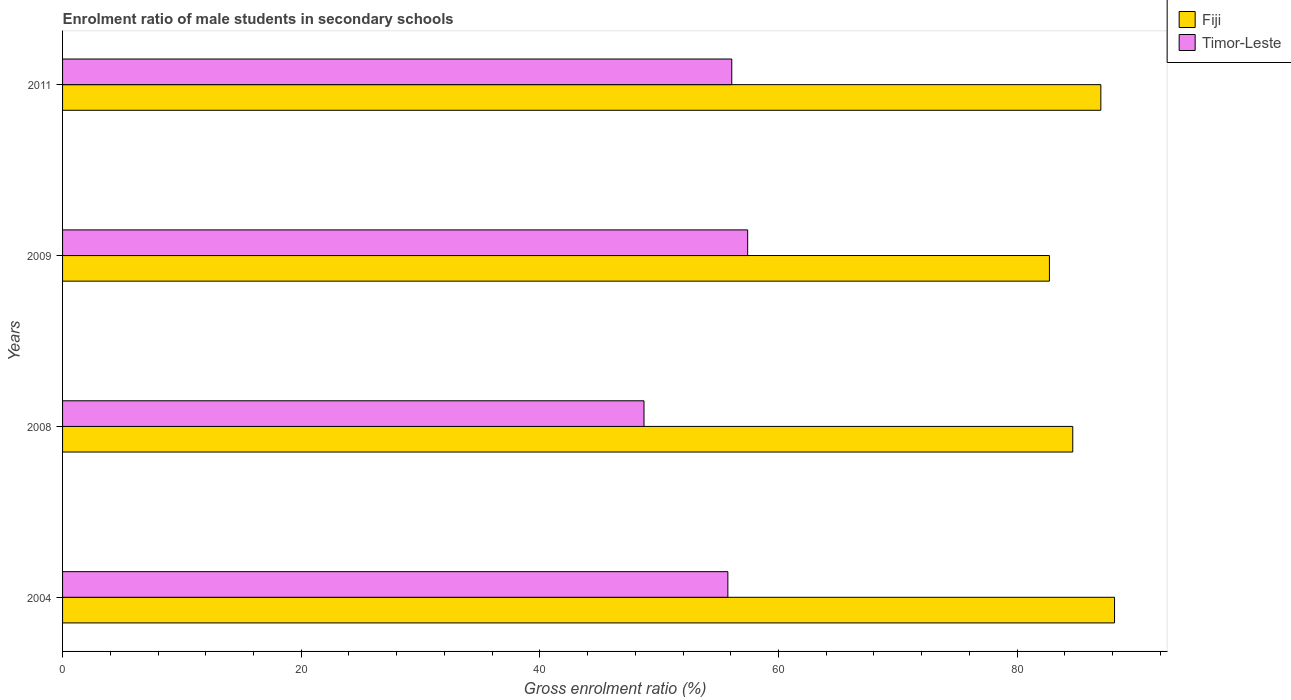How many different coloured bars are there?
Give a very brief answer. 2. How many groups of bars are there?
Ensure brevity in your answer.  4. Are the number of bars per tick equal to the number of legend labels?
Your response must be concise. Yes. Are the number of bars on each tick of the Y-axis equal?
Provide a succinct answer. Yes. What is the label of the 2nd group of bars from the top?
Offer a very short reply. 2009. What is the enrolment ratio of male students in secondary schools in Timor-Leste in 2004?
Offer a very short reply. 55.75. Across all years, what is the maximum enrolment ratio of male students in secondary schools in Fiji?
Keep it short and to the point. 88.16. Across all years, what is the minimum enrolment ratio of male students in secondary schools in Timor-Leste?
Offer a very short reply. 48.73. In which year was the enrolment ratio of male students in secondary schools in Timor-Leste minimum?
Ensure brevity in your answer.  2008. What is the total enrolment ratio of male students in secondary schools in Timor-Leste in the graph?
Provide a succinct answer. 217.98. What is the difference between the enrolment ratio of male students in secondary schools in Fiji in 2008 and that in 2009?
Your answer should be very brief. 1.96. What is the difference between the enrolment ratio of male students in secondary schools in Fiji in 2011 and the enrolment ratio of male students in secondary schools in Timor-Leste in 2008?
Make the answer very short. 38.29. What is the average enrolment ratio of male students in secondary schools in Fiji per year?
Offer a very short reply. 85.63. In the year 2008, what is the difference between the enrolment ratio of male students in secondary schools in Timor-Leste and enrolment ratio of male students in secondary schools in Fiji?
Offer a terse response. -35.93. In how many years, is the enrolment ratio of male students in secondary schools in Fiji greater than 28 %?
Ensure brevity in your answer.  4. What is the ratio of the enrolment ratio of male students in secondary schools in Timor-Leste in 2004 to that in 2011?
Give a very brief answer. 0.99. Is the enrolment ratio of male students in secondary schools in Timor-Leste in 2004 less than that in 2009?
Give a very brief answer. Yes. What is the difference between the highest and the second highest enrolment ratio of male students in secondary schools in Fiji?
Give a very brief answer. 1.15. What is the difference between the highest and the lowest enrolment ratio of male students in secondary schools in Timor-Leste?
Ensure brevity in your answer.  8.69. What does the 2nd bar from the top in 2011 represents?
Offer a terse response. Fiji. What does the 1st bar from the bottom in 2009 represents?
Provide a succinct answer. Fiji. How many bars are there?
Offer a very short reply. 8. How many years are there in the graph?
Your response must be concise. 4. Are the values on the major ticks of X-axis written in scientific E-notation?
Provide a succinct answer. No. Where does the legend appear in the graph?
Keep it short and to the point. Top right. How many legend labels are there?
Your answer should be compact. 2. How are the legend labels stacked?
Your response must be concise. Vertical. What is the title of the graph?
Keep it short and to the point. Enrolment ratio of male students in secondary schools. Does "Samoa" appear as one of the legend labels in the graph?
Give a very brief answer. No. What is the label or title of the X-axis?
Your answer should be compact. Gross enrolment ratio (%). What is the label or title of the Y-axis?
Provide a succinct answer. Years. What is the Gross enrolment ratio (%) of Fiji in 2004?
Keep it short and to the point. 88.16. What is the Gross enrolment ratio (%) of Timor-Leste in 2004?
Offer a terse response. 55.75. What is the Gross enrolment ratio (%) in Fiji in 2008?
Offer a terse response. 84.66. What is the Gross enrolment ratio (%) in Timor-Leste in 2008?
Provide a succinct answer. 48.73. What is the Gross enrolment ratio (%) in Fiji in 2009?
Your answer should be very brief. 82.7. What is the Gross enrolment ratio (%) in Timor-Leste in 2009?
Offer a very short reply. 57.41. What is the Gross enrolment ratio (%) of Fiji in 2011?
Offer a very short reply. 87.01. What is the Gross enrolment ratio (%) of Timor-Leste in 2011?
Provide a succinct answer. 56.08. Across all years, what is the maximum Gross enrolment ratio (%) in Fiji?
Provide a succinct answer. 88.16. Across all years, what is the maximum Gross enrolment ratio (%) in Timor-Leste?
Your answer should be very brief. 57.41. Across all years, what is the minimum Gross enrolment ratio (%) in Fiji?
Provide a succinct answer. 82.7. Across all years, what is the minimum Gross enrolment ratio (%) of Timor-Leste?
Your answer should be compact. 48.73. What is the total Gross enrolment ratio (%) of Fiji in the graph?
Provide a succinct answer. 342.53. What is the total Gross enrolment ratio (%) in Timor-Leste in the graph?
Keep it short and to the point. 217.98. What is the difference between the Gross enrolment ratio (%) in Fiji in 2004 and that in 2008?
Ensure brevity in your answer.  3.5. What is the difference between the Gross enrolment ratio (%) in Timor-Leste in 2004 and that in 2008?
Offer a terse response. 7.03. What is the difference between the Gross enrolment ratio (%) in Fiji in 2004 and that in 2009?
Your answer should be compact. 5.46. What is the difference between the Gross enrolment ratio (%) in Timor-Leste in 2004 and that in 2009?
Give a very brief answer. -1.66. What is the difference between the Gross enrolment ratio (%) of Fiji in 2004 and that in 2011?
Give a very brief answer. 1.15. What is the difference between the Gross enrolment ratio (%) of Timor-Leste in 2004 and that in 2011?
Offer a very short reply. -0.33. What is the difference between the Gross enrolment ratio (%) of Fiji in 2008 and that in 2009?
Your response must be concise. 1.96. What is the difference between the Gross enrolment ratio (%) in Timor-Leste in 2008 and that in 2009?
Make the answer very short. -8.69. What is the difference between the Gross enrolment ratio (%) of Fiji in 2008 and that in 2011?
Provide a succinct answer. -2.35. What is the difference between the Gross enrolment ratio (%) of Timor-Leste in 2008 and that in 2011?
Your answer should be compact. -7.36. What is the difference between the Gross enrolment ratio (%) of Fiji in 2009 and that in 2011?
Offer a very short reply. -4.31. What is the difference between the Gross enrolment ratio (%) of Timor-Leste in 2009 and that in 2011?
Your answer should be very brief. 1.33. What is the difference between the Gross enrolment ratio (%) in Fiji in 2004 and the Gross enrolment ratio (%) in Timor-Leste in 2008?
Make the answer very short. 39.43. What is the difference between the Gross enrolment ratio (%) of Fiji in 2004 and the Gross enrolment ratio (%) of Timor-Leste in 2009?
Your response must be concise. 30.75. What is the difference between the Gross enrolment ratio (%) in Fiji in 2004 and the Gross enrolment ratio (%) in Timor-Leste in 2011?
Offer a very short reply. 32.08. What is the difference between the Gross enrolment ratio (%) of Fiji in 2008 and the Gross enrolment ratio (%) of Timor-Leste in 2009?
Provide a short and direct response. 27.24. What is the difference between the Gross enrolment ratio (%) in Fiji in 2008 and the Gross enrolment ratio (%) in Timor-Leste in 2011?
Your response must be concise. 28.58. What is the difference between the Gross enrolment ratio (%) in Fiji in 2009 and the Gross enrolment ratio (%) in Timor-Leste in 2011?
Your response must be concise. 26.62. What is the average Gross enrolment ratio (%) in Fiji per year?
Your answer should be compact. 85.63. What is the average Gross enrolment ratio (%) of Timor-Leste per year?
Offer a terse response. 54.49. In the year 2004, what is the difference between the Gross enrolment ratio (%) of Fiji and Gross enrolment ratio (%) of Timor-Leste?
Give a very brief answer. 32.41. In the year 2008, what is the difference between the Gross enrolment ratio (%) of Fiji and Gross enrolment ratio (%) of Timor-Leste?
Keep it short and to the point. 35.93. In the year 2009, what is the difference between the Gross enrolment ratio (%) of Fiji and Gross enrolment ratio (%) of Timor-Leste?
Provide a short and direct response. 25.29. In the year 2011, what is the difference between the Gross enrolment ratio (%) in Fiji and Gross enrolment ratio (%) in Timor-Leste?
Make the answer very short. 30.93. What is the ratio of the Gross enrolment ratio (%) of Fiji in 2004 to that in 2008?
Your answer should be very brief. 1.04. What is the ratio of the Gross enrolment ratio (%) in Timor-Leste in 2004 to that in 2008?
Provide a short and direct response. 1.14. What is the ratio of the Gross enrolment ratio (%) in Fiji in 2004 to that in 2009?
Offer a terse response. 1.07. What is the ratio of the Gross enrolment ratio (%) of Timor-Leste in 2004 to that in 2009?
Keep it short and to the point. 0.97. What is the ratio of the Gross enrolment ratio (%) of Fiji in 2004 to that in 2011?
Provide a succinct answer. 1.01. What is the ratio of the Gross enrolment ratio (%) in Timor-Leste in 2004 to that in 2011?
Offer a very short reply. 0.99. What is the ratio of the Gross enrolment ratio (%) in Fiji in 2008 to that in 2009?
Make the answer very short. 1.02. What is the ratio of the Gross enrolment ratio (%) of Timor-Leste in 2008 to that in 2009?
Keep it short and to the point. 0.85. What is the ratio of the Gross enrolment ratio (%) in Fiji in 2008 to that in 2011?
Your response must be concise. 0.97. What is the ratio of the Gross enrolment ratio (%) of Timor-Leste in 2008 to that in 2011?
Your answer should be very brief. 0.87. What is the ratio of the Gross enrolment ratio (%) of Fiji in 2009 to that in 2011?
Keep it short and to the point. 0.95. What is the ratio of the Gross enrolment ratio (%) of Timor-Leste in 2009 to that in 2011?
Your response must be concise. 1.02. What is the difference between the highest and the second highest Gross enrolment ratio (%) in Fiji?
Provide a succinct answer. 1.15. What is the difference between the highest and the second highest Gross enrolment ratio (%) in Timor-Leste?
Provide a succinct answer. 1.33. What is the difference between the highest and the lowest Gross enrolment ratio (%) of Fiji?
Offer a very short reply. 5.46. What is the difference between the highest and the lowest Gross enrolment ratio (%) of Timor-Leste?
Provide a succinct answer. 8.69. 